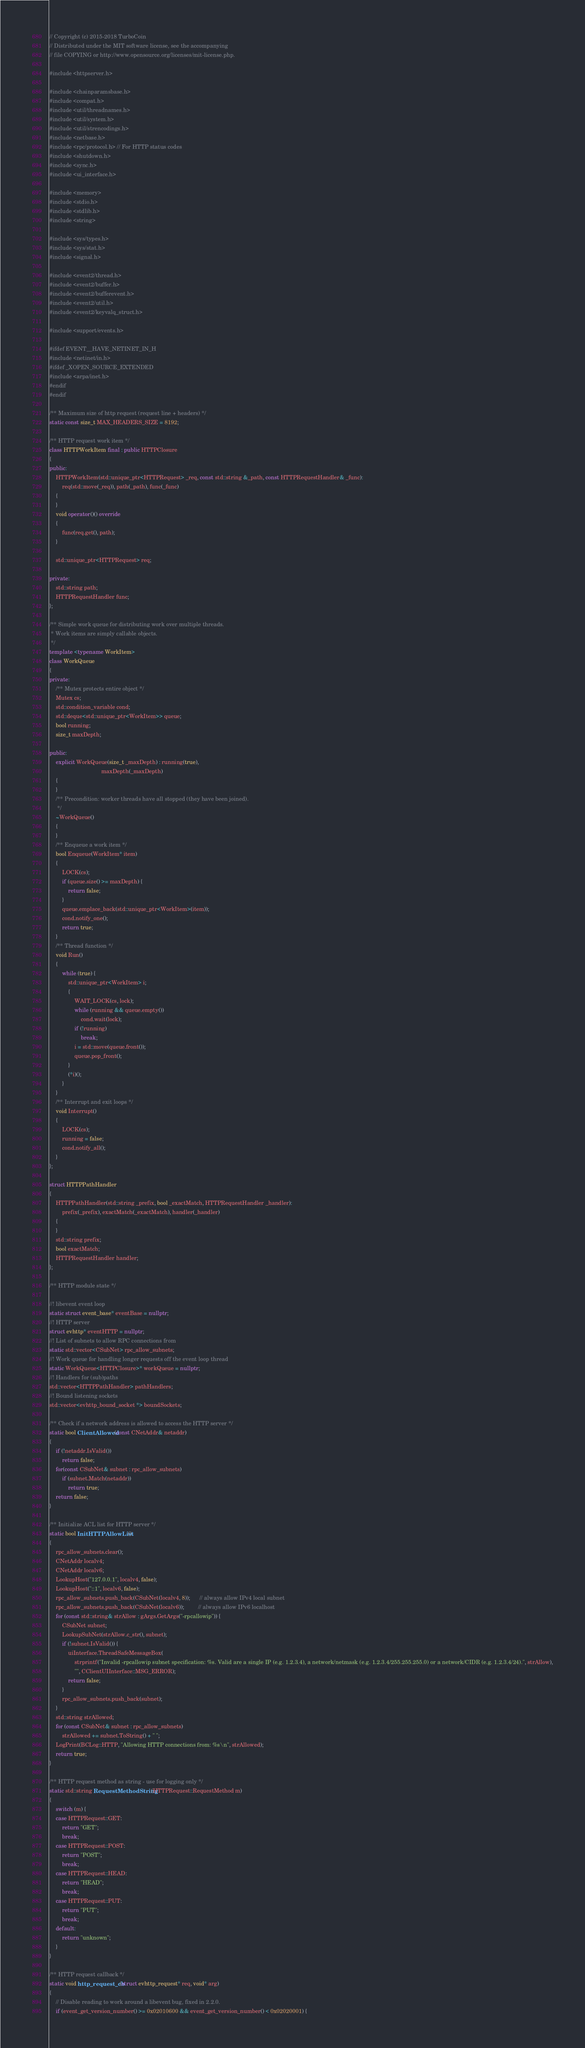Convert code to text. <code><loc_0><loc_0><loc_500><loc_500><_C++_>// Copyright (c) 2015-2018 TurboCoin
// Distributed under the MIT software license, see the accompanying
// file COPYING or http://www.opensource.org/licenses/mit-license.php.

#include <httpserver.h>

#include <chainparamsbase.h>
#include <compat.h>
#include <util/threadnames.h>
#include <util/system.h>
#include <util/strencodings.h>
#include <netbase.h>
#include <rpc/protocol.h> // For HTTP status codes
#include <shutdown.h>
#include <sync.h>
#include <ui_interface.h>

#include <memory>
#include <stdio.h>
#include <stdlib.h>
#include <string>

#include <sys/types.h>
#include <sys/stat.h>
#include <signal.h>

#include <event2/thread.h>
#include <event2/buffer.h>
#include <event2/bufferevent.h>
#include <event2/util.h>
#include <event2/keyvalq_struct.h>

#include <support/events.h>

#ifdef EVENT__HAVE_NETINET_IN_H
#include <netinet/in.h>
#ifdef _XOPEN_SOURCE_EXTENDED
#include <arpa/inet.h>
#endif
#endif

/** Maximum size of http request (request line + headers) */
static const size_t MAX_HEADERS_SIZE = 8192;

/** HTTP request work item */
class HTTPWorkItem final : public HTTPClosure
{
public:
    HTTPWorkItem(std::unique_ptr<HTTPRequest> _req, const std::string &_path, const HTTPRequestHandler& _func):
        req(std::move(_req)), path(_path), func(_func)
    {
    }
    void operator()() override
    {
        func(req.get(), path);
    }

    std::unique_ptr<HTTPRequest> req;

private:
    std::string path;
    HTTPRequestHandler func;
};

/** Simple work queue for distributing work over multiple threads.
 * Work items are simply callable objects.
 */
template <typename WorkItem>
class WorkQueue
{
private:
    /** Mutex protects entire object */
    Mutex cs;
    std::condition_variable cond;
    std::deque<std::unique_ptr<WorkItem>> queue;
    bool running;
    size_t maxDepth;

public:
    explicit WorkQueue(size_t _maxDepth) : running(true),
                                 maxDepth(_maxDepth)
    {
    }
    /** Precondition: worker threads have all stopped (they have been joined).
     */
    ~WorkQueue()
    {
    }
    /** Enqueue a work item */
    bool Enqueue(WorkItem* item)
    {
        LOCK(cs);
        if (queue.size() >= maxDepth) {
            return false;
        }
        queue.emplace_back(std::unique_ptr<WorkItem>(item));
        cond.notify_one();
        return true;
    }
    /** Thread function */
    void Run()
    {
        while (true) {
            std::unique_ptr<WorkItem> i;
            {
                WAIT_LOCK(cs, lock);
                while (running && queue.empty())
                    cond.wait(lock);
                if (!running)
                    break;
                i = std::move(queue.front());
                queue.pop_front();
            }
            (*i)();
        }
    }
    /** Interrupt and exit loops */
    void Interrupt()
    {
        LOCK(cs);
        running = false;
        cond.notify_all();
    }
};

struct HTTPPathHandler
{
    HTTPPathHandler(std::string _prefix, bool _exactMatch, HTTPRequestHandler _handler):
        prefix(_prefix), exactMatch(_exactMatch), handler(_handler)
    {
    }
    std::string prefix;
    bool exactMatch;
    HTTPRequestHandler handler;
};

/** HTTP module state */

//! libevent event loop
static struct event_base* eventBase = nullptr;
//! HTTP server
struct evhttp* eventHTTP = nullptr;
//! List of subnets to allow RPC connections from
static std::vector<CSubNet> rpc_allow_subnets;
//! Work queue for handling longer requests off the event loop thread
static WorkQueue<HTTPClosure>* workQueue = nullptr;
//! Handlers for (sub)paths
std::vector<HTTPPathHandler> pathHandlers;
//! Bound listening sockets
std::vector<evhttp_bound_socket *> boundSockets;

/** Check if a network address is allowed to access the HTTP server */
static bool ClientAllowed(const CNetAddr& netaddr)
{
    if (!netaddr.IsValid())
        return false;
    for(const CSubNet& subnet : rpc_allow_subnets)
        if (subnet.Match(netaddr))
            return true;
    return false;
}

/** Initialize ACL list for HTTP server */
static bool InitHTTPAllowList()
{
    rpc_allow_subnets.clear();
    CNetAddr localv4;
    CNetAddr localv6;
    LookupHost("127.0.0.1", localv4, false);
    LookupHost("::1", localv6, false);
    rpc_allow_subnets.push_back(CSubNet(localv4, 8));      // always allow IPv4 local subnet
    rpc_allow_subnets.push_back(CSubNet(localv6));         // always allow IPv6 localhost
    for (const std::string& strAllow : gArgs.GetArgs("-rpcallowip")) {
        CSubNet subnet;
        LookupSubNet(strAllow.c_str(), subnet);
        if (!subnet.IsValid()) {
            uiInterface.ThreadSafeMessageBox(
                strprintf("Invalid -rpcallowip subnet specification: %s. Valid are a single IP (e.g. 1.2.3.4), a network/netmask (e.g. 1.2.3.4/255.255.255.0) or a network/CIDR (e.g. 1.2.3.4/24).", strAllow),
                "", CClientUIInterface::MSG_ERROR);
            return false;
        }
        rpc_allow_subnets.push_back(subnet);
    }
    std::string strAllowed;
    for (const CSubNet& subnet : rpc_allow_subnets)
        strAllowed += subnet.ToString() + " ";
    LogPrint(BCLog::HTTP, "Allowing HTTP connections from: %s\n", strAllowed);
    return true;
}

/** HTTP request method as string - use for logging only */
static std::string RequestMethodString(HTTPRequest::RequestMethod m)
{
    switch (m) {
    case HTTPRequest::GET:
        return "GET";
        break;
    case HTTPRequest::POST:
        return "POST";
        break;
    case HTTPRequest::HEAD:
        return "HEAD";
        break;
    case HTTPRequest::PUT:
        return "PUT";
        break;
    default:
        return "unknown";
    }
}

/** HTTP request callback */
static void http_request_cb(struct evhttp_request* req, void* arg)
{
    // Disable reading to work around a libevent bug, fixed in 2.2.0.
    if (event_get_version_number() >= 0x02010600 && event_get_version_number() < 0x02020001) {</code> 